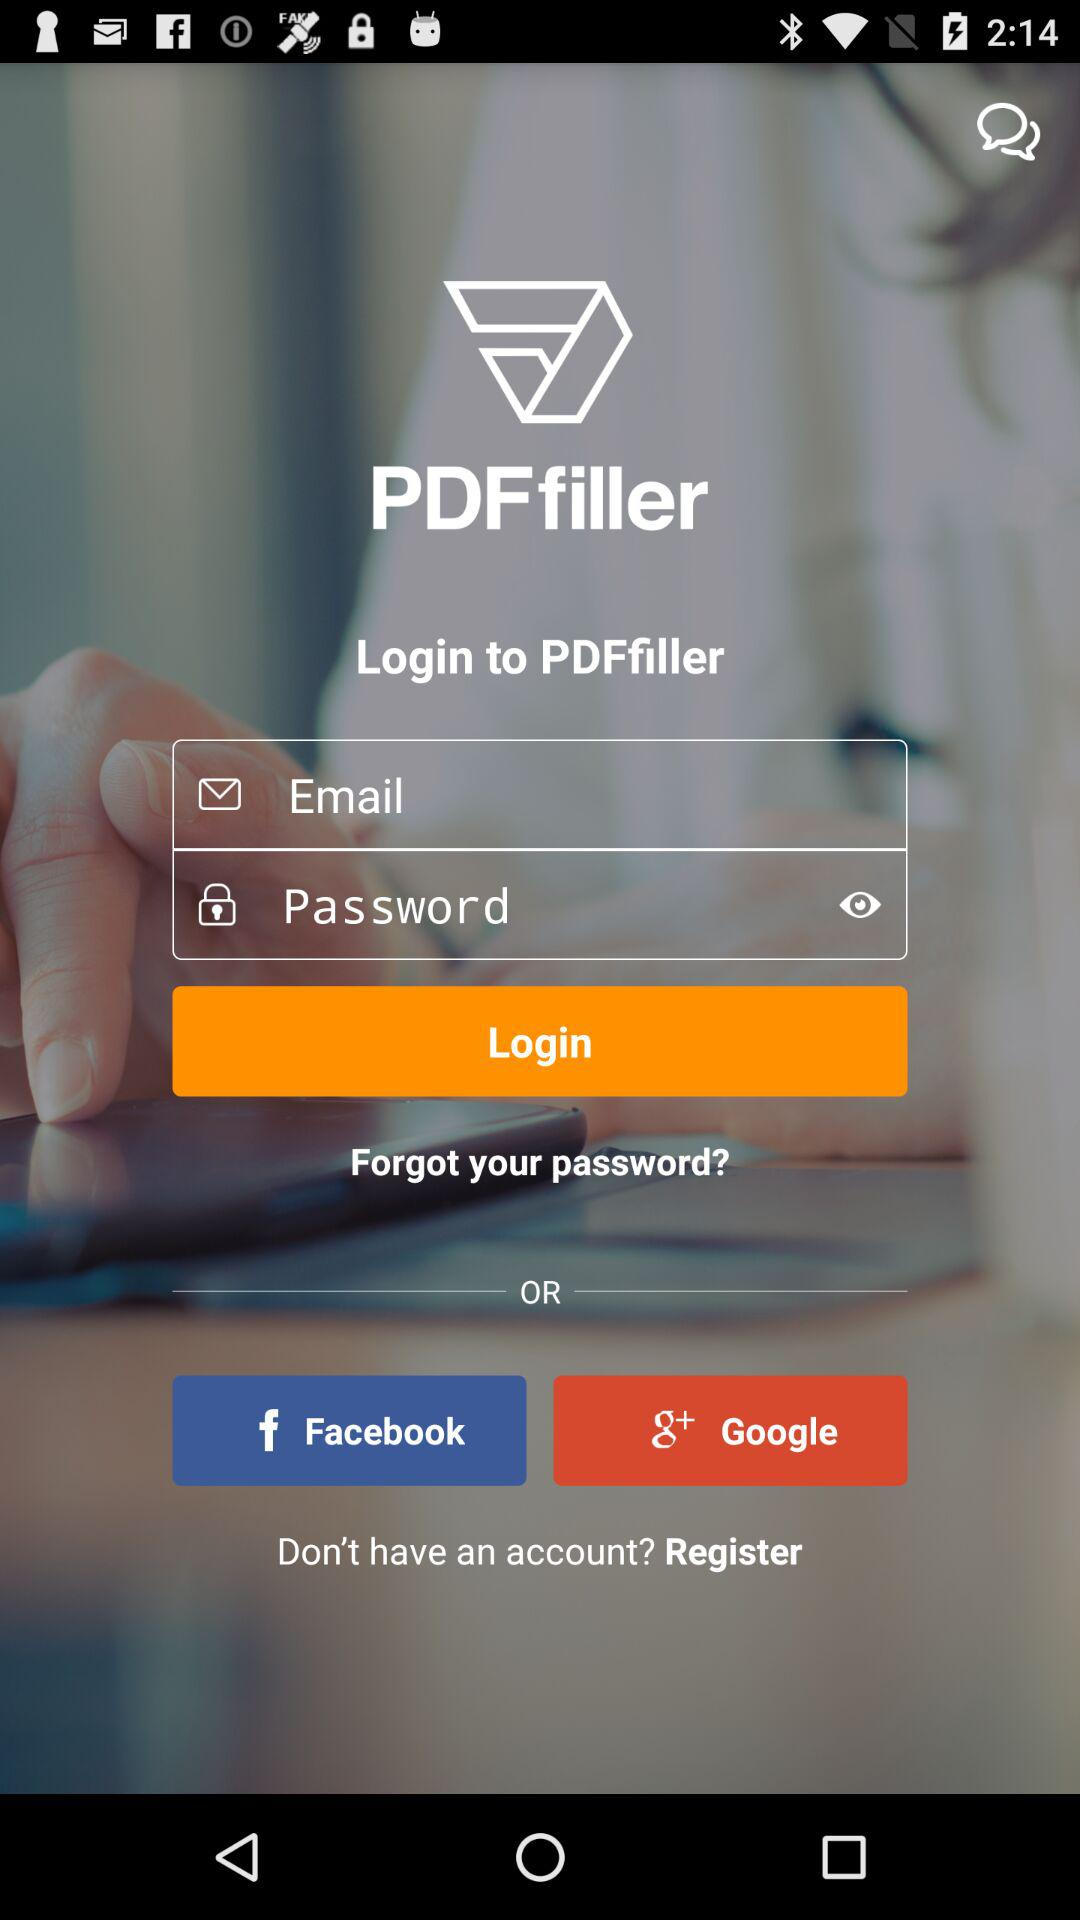How many inputs are there on this login screen?
Answer the question using a single word or phrase. 2 